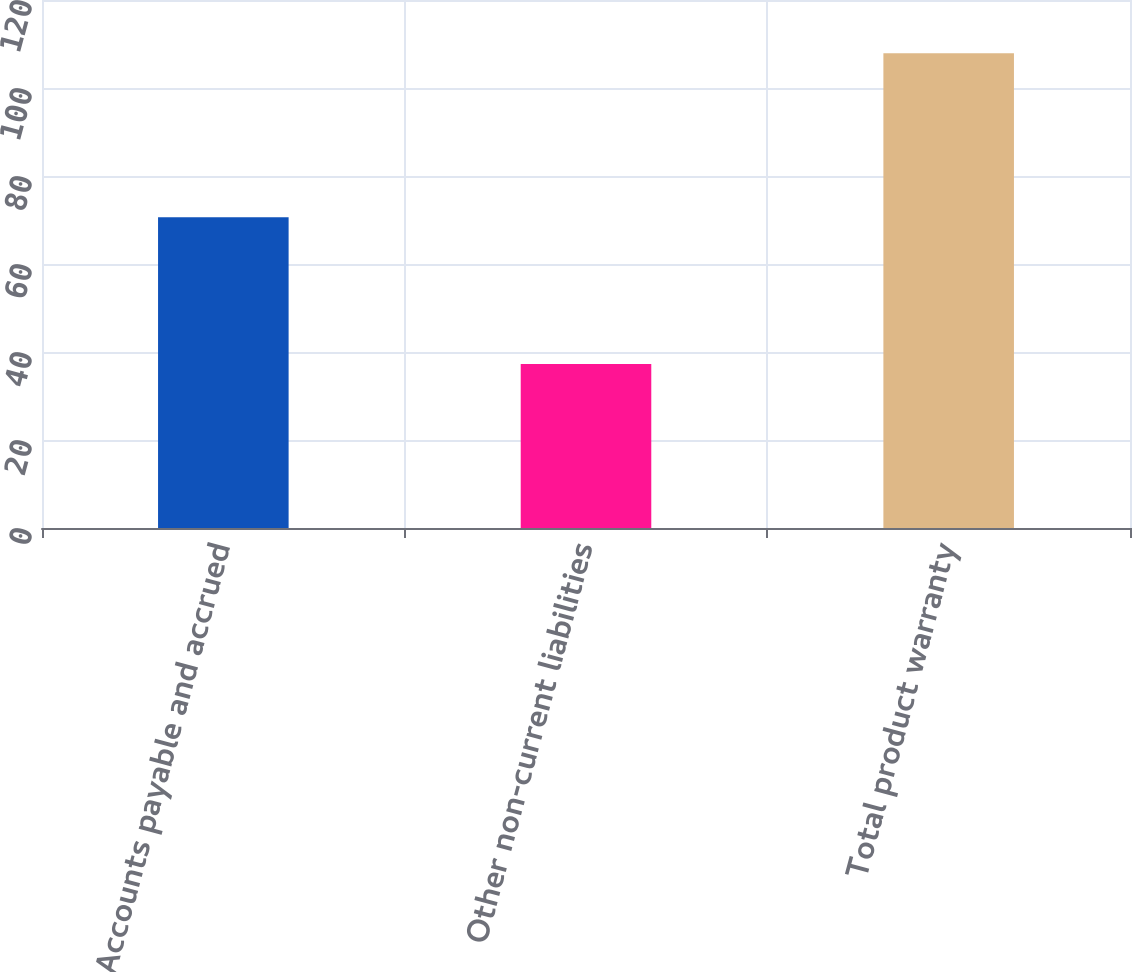Convert chart to OTSL. <chart><loc_0><loc_0><loc_500><loc_500><bar_chart><fcel>Accounts payable and accrued<fcel>Other non-current liabilities<fcel>Total product warranty<nl><fcel>70.6<fcel>37.3<fcel>107.9<nl></chart> 